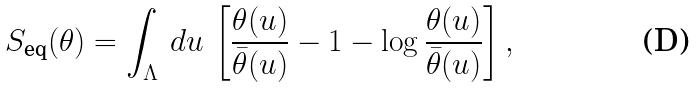Convert formula to latex. <formula><loc_0><loc_0><loc_500><loc_500>S _ { \text {eq} } ( \theta ) = \int _ { \Lambda } \, d u \, \left [ \frac { \theta ( u ) } { \bar { \theta } ( u ) } - 1 - \log \frac { \theta ( u ) } { \bar { \theta } ( u ) } \right ] ,</formula> 